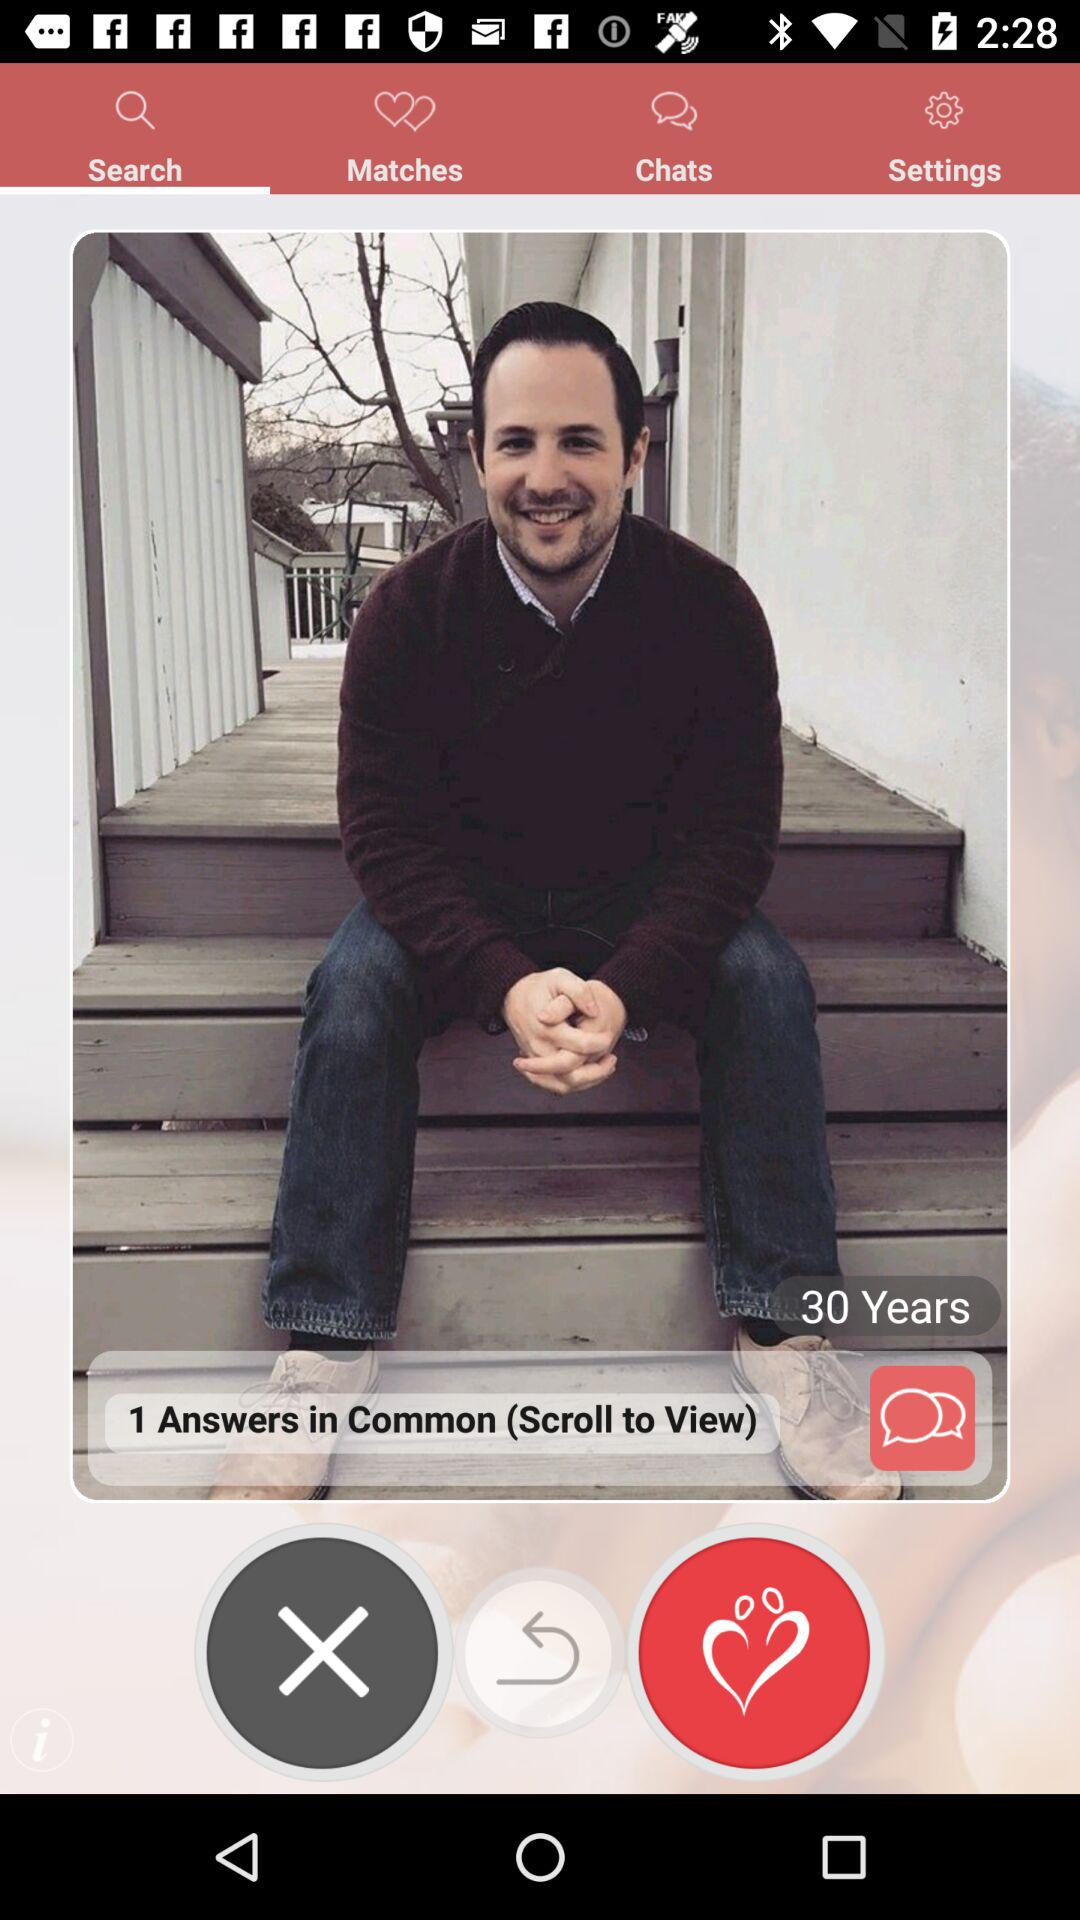What is the age? The age is 30 years old. 